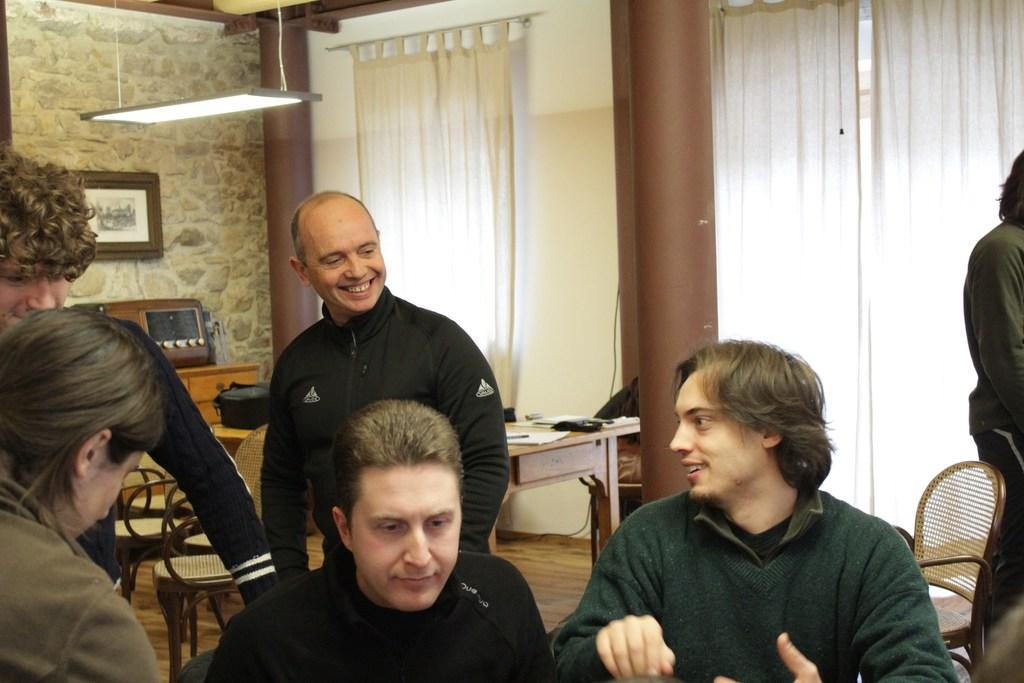How many people are in the image? There are people in the image, but the exact number cannot be determined from the provided facts. What type of furniture is present in the image? There are chairs and a table in the image. What type of appliance can be seen in the image? There is an oven in the image. What type of decorative item is present in the image? There is a photo frame in the image. What type of lighting is present in the image? There is a light in the image. What type of architectural feature is present in the image? There is a wall in the image. What type of window treatment is present in the image? There are curtains in the image. What object is on the table in the image? There is a bag on the table in the image. How many apples are on the table in the image? There is no mention of apples in the image, so we cannot determine the number of apples present. What type of jewel is hanging from the light in the image? There is no mention of a jewel in the image, so we cannot determine if one is present or not. 